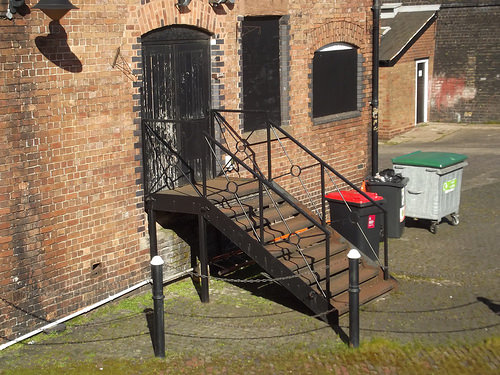<image>
Can you confirm if the shadow is on the wall? Yes. Looking at the image, I can see the shadow is positioned on top of the wall, with the wall providing support. 